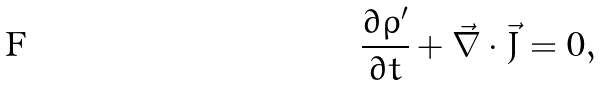Convert formula to latex. <formula><loc_0><loc_0><loc_500><loc_500>\frac { \partial \rho ^ { \prime } } { \partial t } + \vec { \nabla } \cdot \vec { J } = 0 ,</formula> 